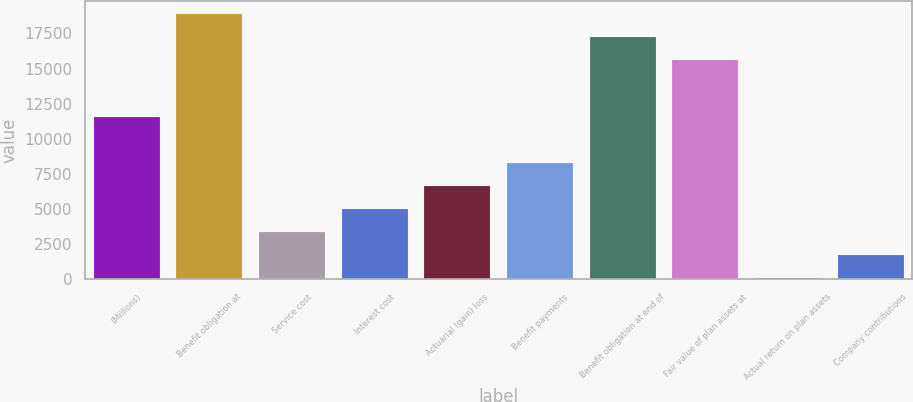Convert chart to OTSL. <chart><loc_0><loc_0><loc_500><loc_500><bar_chart><fcel>(Millions)<fcel>Benefit obligation at<fcel>Service cost<fcel>Interest cost<fcel>Actuarial (gain) loss<fcel>Benefit payments<fcel>Benefit obligation at end of<fcel>Fair value of plan assets at<fcel>Actual return on plan assets<fcel>Company contributions<nl><fcel>11546.4<fcel>18871.6<fcel>3370.4<fcel>5005.6<fcel>6640.8<fcel>8276<fcel>17236.4<fcel>15601.2<fcel>100<fcel>1735.2<nl></chart> 